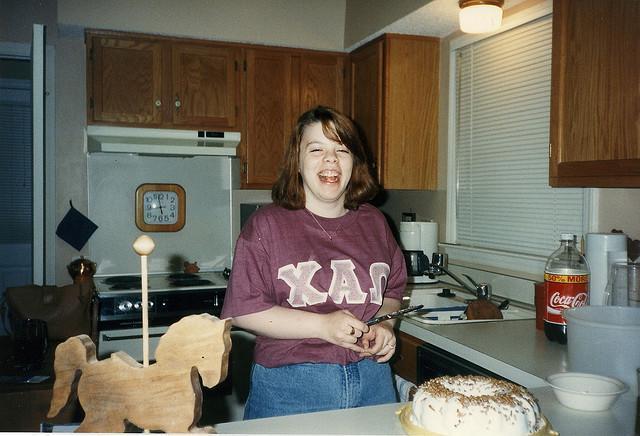How many bowls can you see?
Give a very brief answer. 1. 